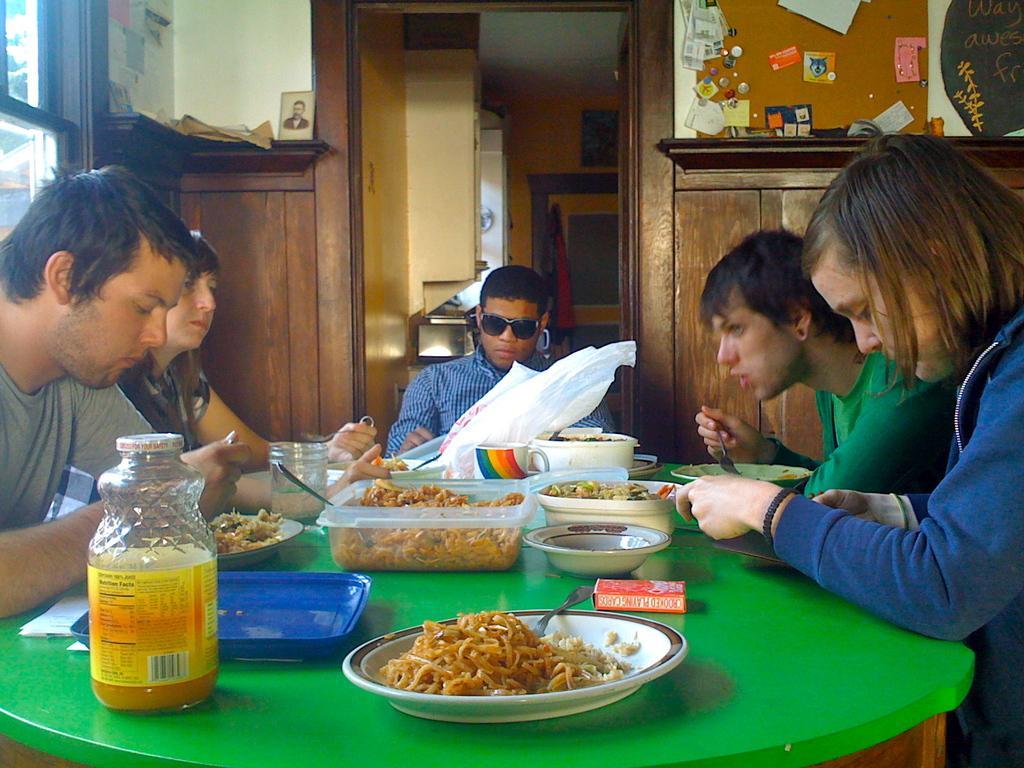In one or two sentences, can you explain what this image depicts? In this picture there is a dining table in the center of the image and there are people around it, table contains food items and plates on it, there is a door at the top side of the image. 